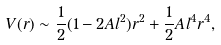<formula> <loc_0><loc_0><loc_500><loc_500>V ( r ) \sim \frac { 1 } { 2 } ( 1 - 2 A l ^ { 2 } ) r ^ { 2 } + \frac { 1 } { 2 } A l ^ { 4 } r ^ { 4 } ,</formula> 